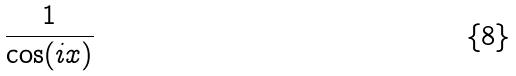<formula> <loc_0><loc_0><loc_500><loc_500>\frac { 1 } { \cos ( i x ) }</formula> 